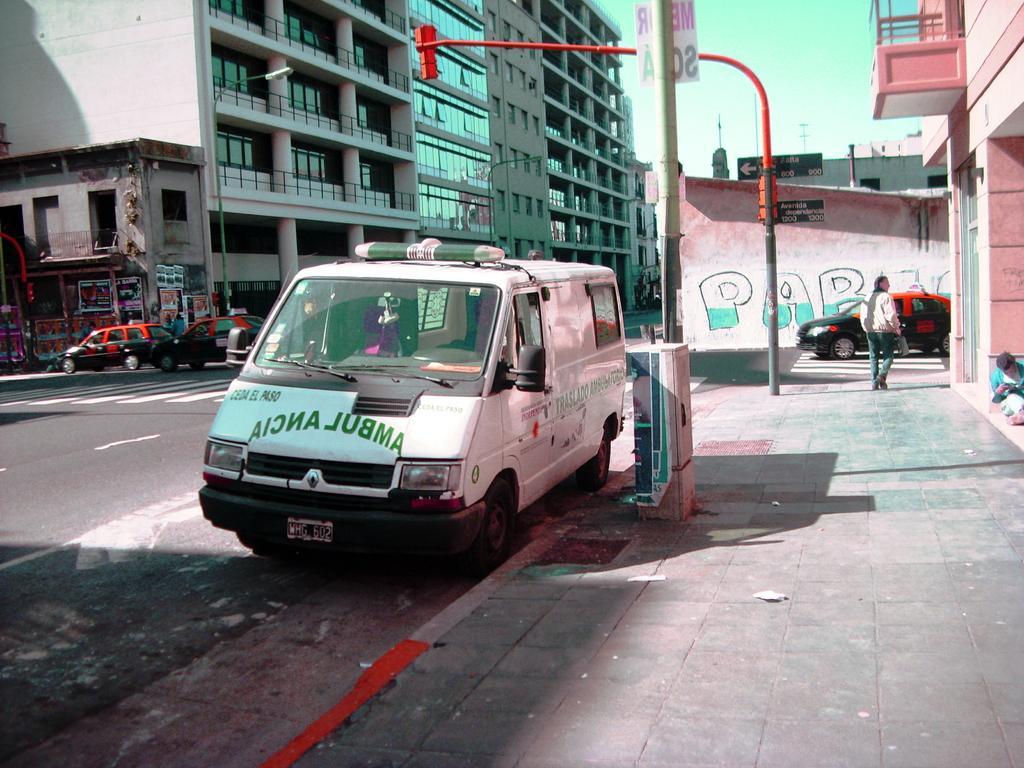Could you give a brief overview of what you see in this image? In this picture we can see the buildings, traffic lights, poles, boards, graffiti on the wall, some vehicles, pillars, persons, balcony. At the bottom of the image we can see the footpath. On the left side of the image we can see the road. At the top of the image we can see the sky. 